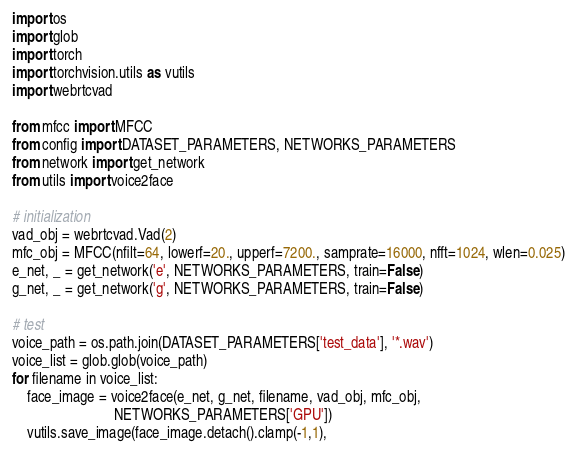<code> <loc_0><loc_0><loc_500><loc_500><_Python_>import os
import glob
import torch
import torchvision.utils as vutils
import webrtcvad

from mfcc import MFCC
from config import DATASET_PARAMETERS, NETWORKS_PARAMETERS
from network import get_network
from utils import voice2face

# initialization
vad_obj = webrtcvad.Vad(2)
mfc_obj = MFCC(nfilt=64, lowerf=20., upperf=7200., samprate=16000, nfft=1024, wlen=0.025)
e_net, _ = get_network('e', NETWORKS_PARAMETERS, train=False)
g_net, _ = get_network('g', NETWORKS_PARAMETERS, train=False)

# test
voice_path = os.path.join(DATASET_PARAMETERS['test_data'], '*.wav')
voice_list = glob.glob(voice_path)
for filename in voice_list:
    face_image = voice2face(e_net, g_net, filename, vad_obj, mfc_obj,
                            NETWORKS_PARAMETERS['GPU'])
    vutils.save_image(face_image.detach().clamp(-1,1),</code> 